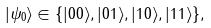Convert formula to latex. <formula><loc_0><loc_0><loc_500><loc_500>| \psi _ { 0 } \rangle \in \{ | 0 0 \rangle , | 0 1 \rangle , | 1 0 \rangle , | 1 1 \rangle \} ,</formula> 